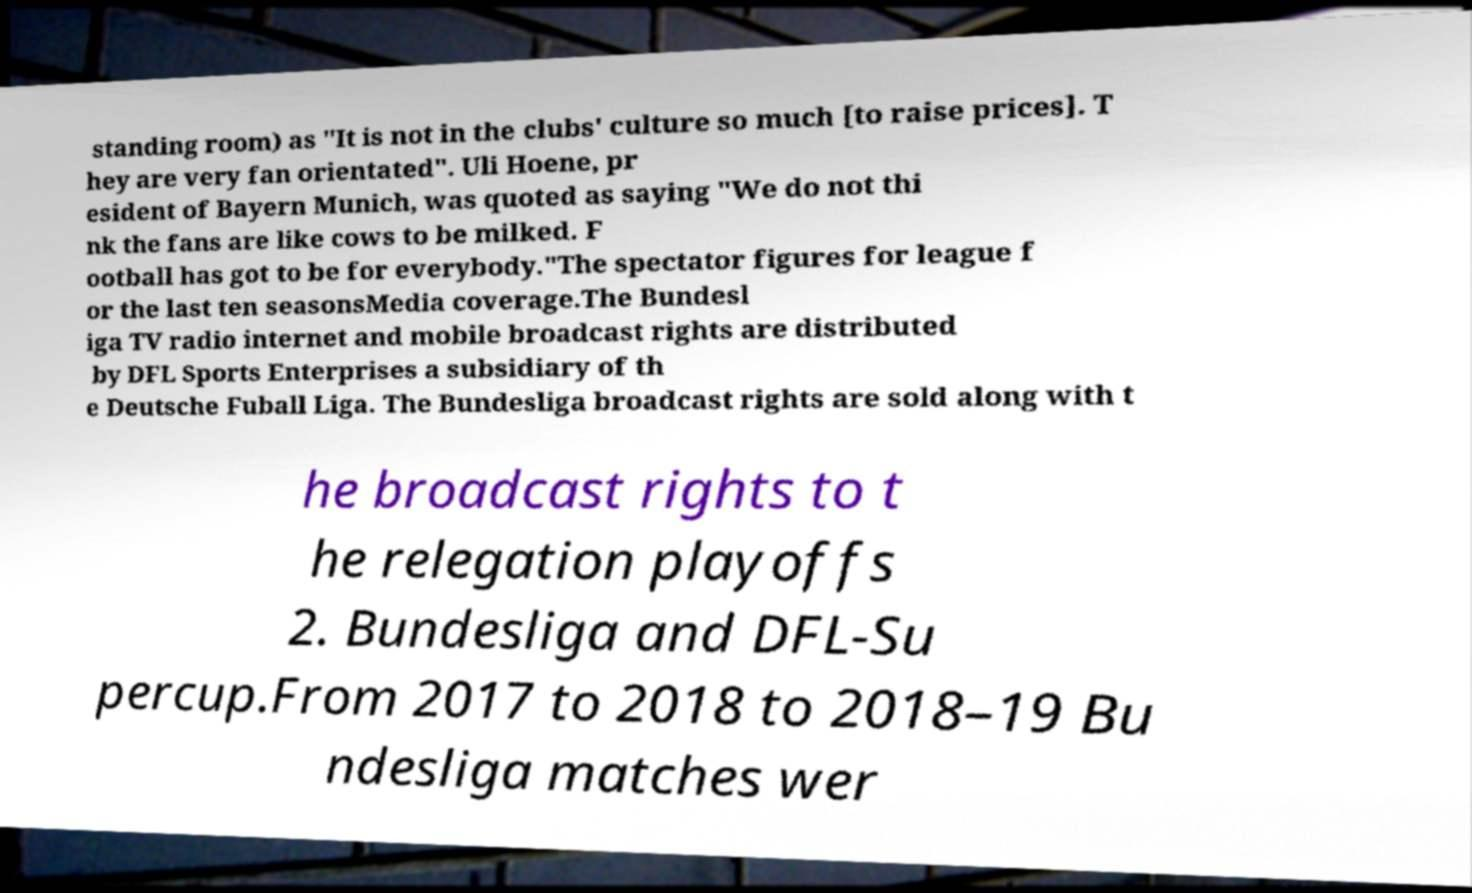Please read and relay the text visible in this image. What does it say? standing room) as "It is not in the clubs' culture so much [to raise prices]. T hey are very fan orientated". Uli Hoene, pr esident of Bayern Munich, was quoted as saying "We do not thi nk the fans are like cows to be milked. F ootball has got to be for everybody."The spectator figures for league f or the last ten seasonsMedia coverage.The Bundesl iga TV radio internet and mobile broadcast rights are distributed by DFL Sports Enterprises a subsidiary of th e Deutsche Fuball Liga. The Bundesliga broadcast rights are sold along with t he broadcast rights to t he relegation playoffs 2. Bundesliga and DFL-Su percup.From 2017 to 2018 to 2018–19 Bu ndesliga matches wer 